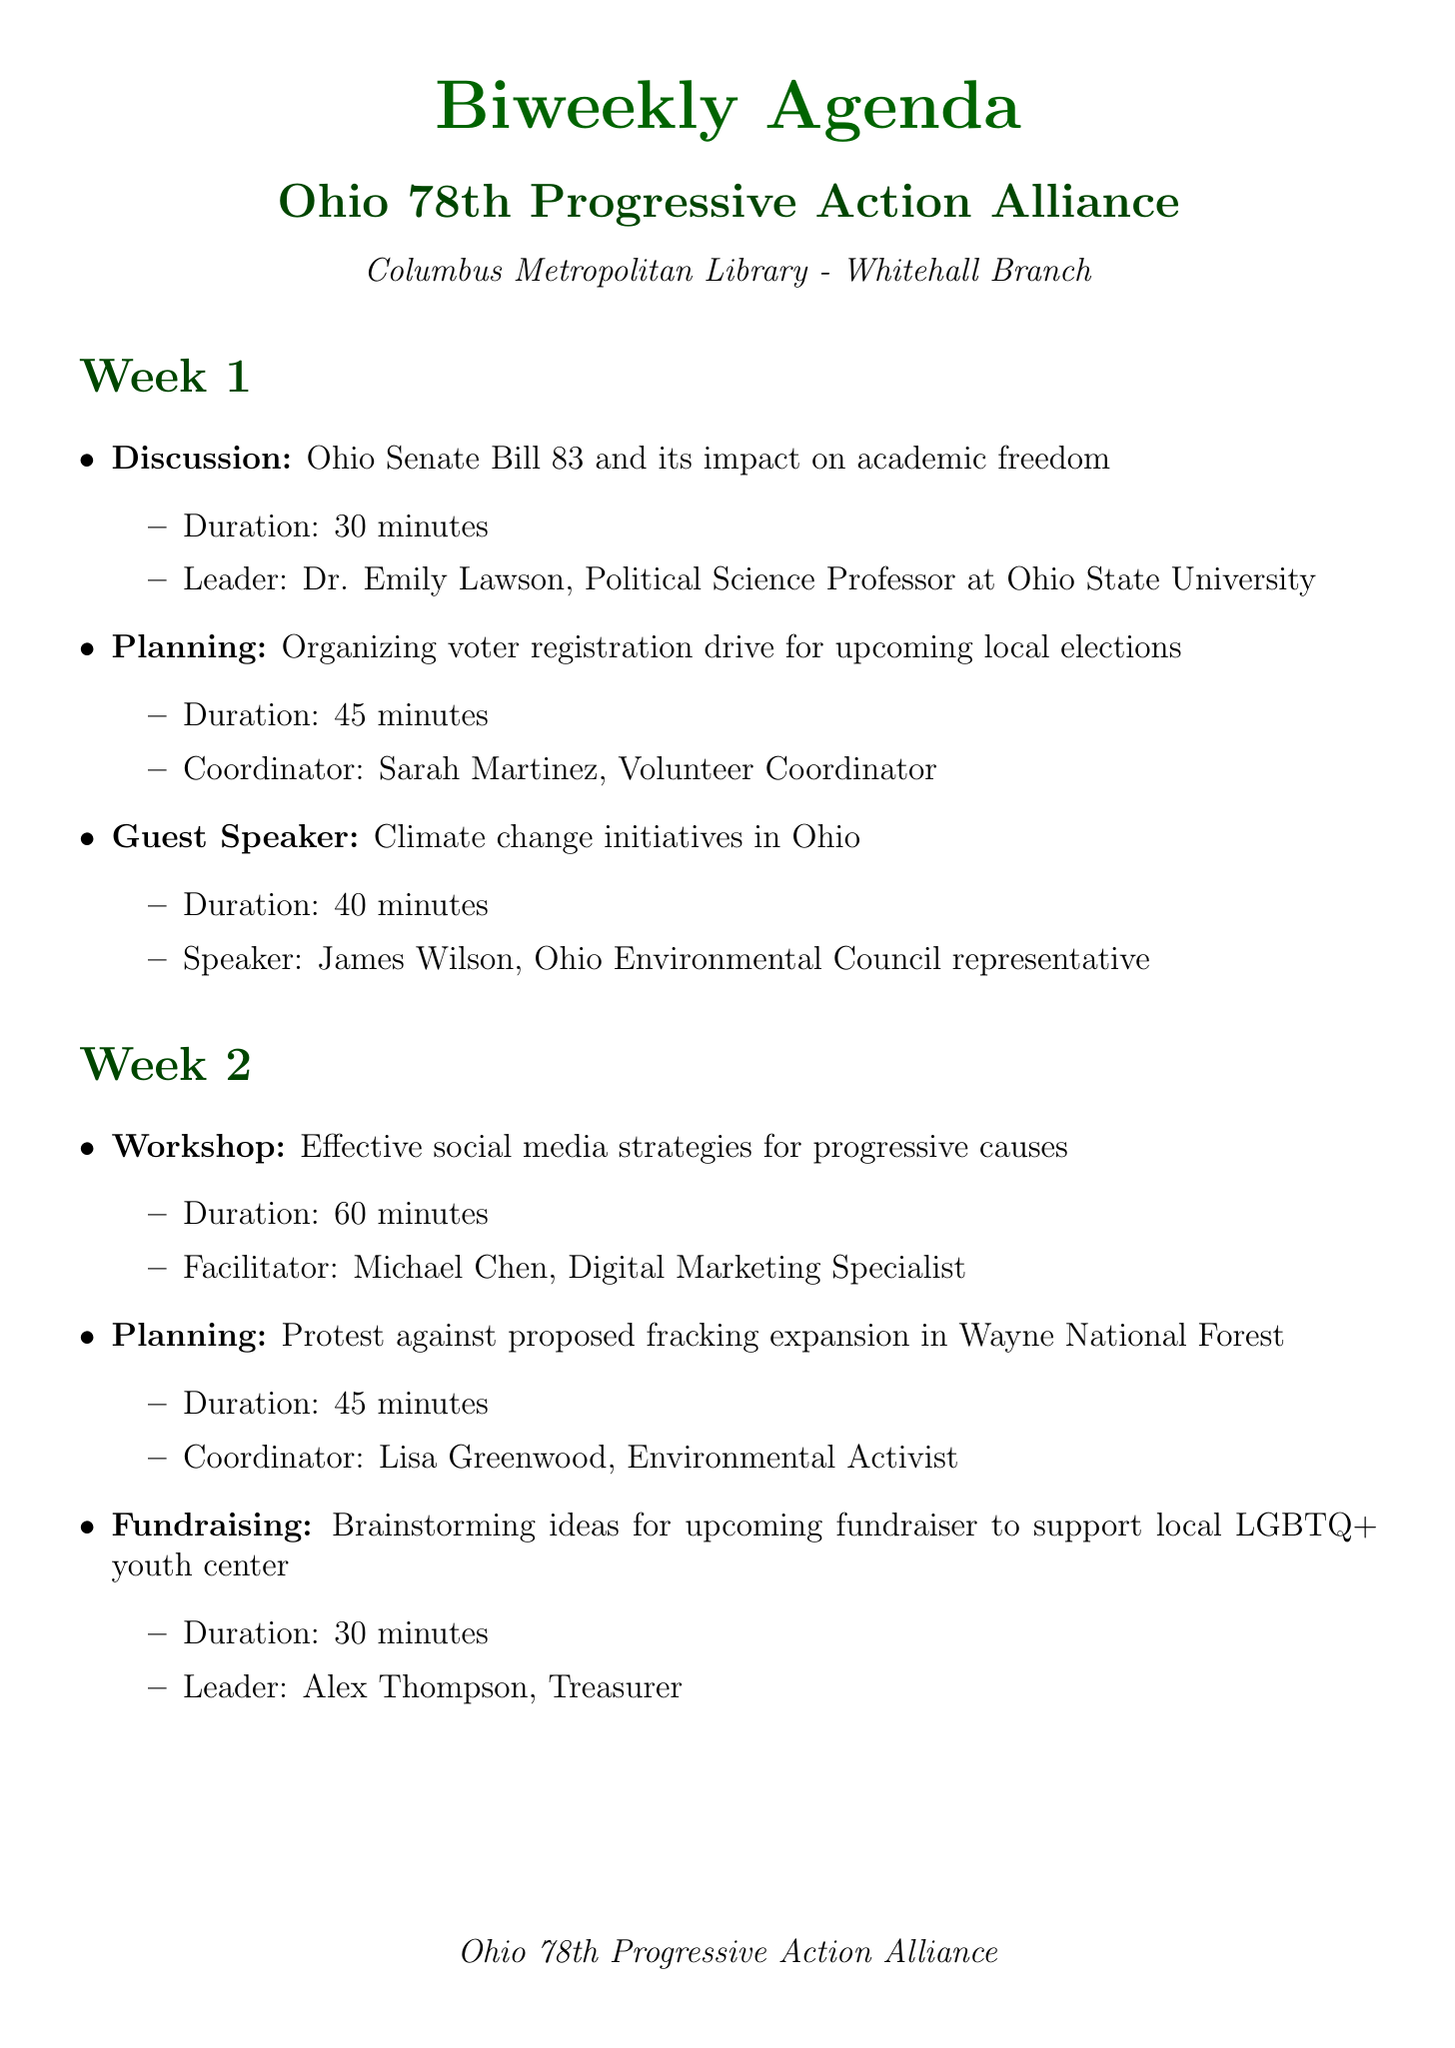What is the location of the meetings? The location of the meetings is specified as the Columbus Metropolitan Library - Whitehall Branch.
Answer: Columbus Metropolitan Library - Whitehall Branch Who is the guest speaker in week 1? The document lists a guest speaker for week 1, which is James Wilson, representing the Ohio Environmental Council.
Answer: James Wilson How long is the workshop in week 2? The workshop in week 2 is noted to be scheduled for 60 minutes.
Answer: 60 minutes What topic will be discussed in week 4 regarding voter suppression? The document mentions a discussion on strategies to combat voter suppression in Ohio during week 4.
Answer: Strategies to combat voter suppression in Ohio Which initiative occurs every Tuesday? The document specifies a weekly phone banking initiative that occurs every Tuesday from 6-8 PM.
Answer: Weekly phone banking for Democratic candidates What is the role of Sarah Martinez? The document details that Sarah Martinez is the Volunteer Coordinator, who is responsible for planning a voter registration drive in week 1.
Answer: Volunteer Coordinator How many protests are listed in the upcoming section? The document presents two protests listed in the upcoming section.
Answer: Two What is the focus of the training scheduled in week 3? The document indicates that the training in week 3 will focus on nonviolent protest techniques and legal rights.
Answer: Nonviolent protest techniques and legal rights 